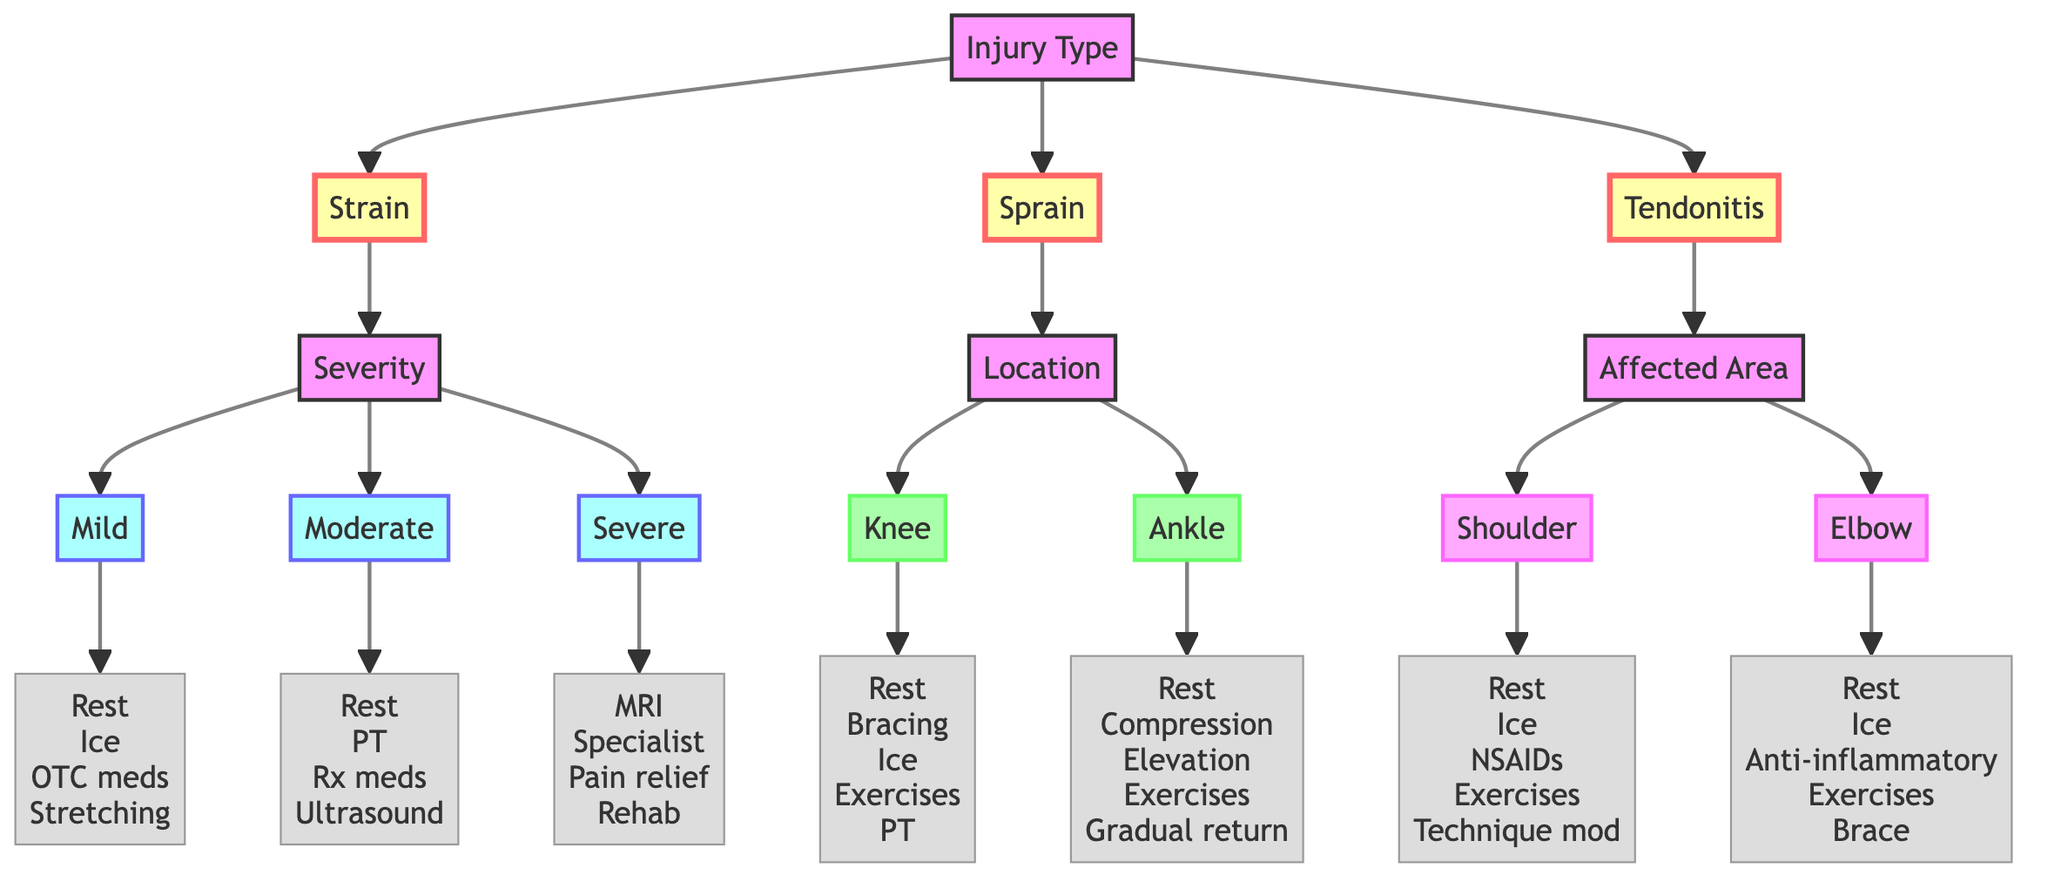What are the three injury types listed in this diagram? The diagram displays three injury types: Strain, Sprain, and Tendonitis which are the main branches stemming from the root node "Injury Type."
Answer: Strain, Sprain, Tendonitis What treatments are recommended for a severe strain? For a severe strain, the recommended treatments include MRI for detailed imaging, consultation with an orthopedic specialist, prescription pain relief, and a rehabilitation program, as indicated in the flowchart.
Answer: MRI, specialist, pain relief, rehab How many options are there under the "Sprain" injury type? The "Sprain" injury type has two options listed under it: Knee and Ankle, indicating the locations where the sprains can occur. Thus, there are two options.
Answer: 2 What is the node following the "Tendonitis" branch? The node following the "Tendonitis" branch is "Affected Area," which provides further classification of the injury by specifying the area that is affected, leading to subsequent specific areas.
Answer: Affected Area What is the treatment for "Elbow" tendonitis? The treatment options for "Elbow" tendonitis include rest, ice application, anti-inflammatory medication, forearm and grip strengthening exercises, and brace or support, as stated in the diagram.
Answer: Rest, Ice, Anti-inflammatory, Exercises, Brace If someone has a knee sprain, what is the first treatment they should consider? For a knee sprain, the first treatment recommended is rest. This comes from the flowchart, where "Rest" is listed as the first option under the knee location treatments.
Answer: Rest What is the common cause of shoulder tendonitis as noted in the diagram? The common cause of shoulder tendonitis is identified in the description as overhead movements and bench press, which are typical activities that can lead to this injury among powerlifters.
Answer: Overhead movements, bench press What are the mild strain treatments listed? The treatments for a mild strain include rest, ice application, over-the-counter anti-inflammatory medication, and light stretching, which are organized sequentially in the diagram under the mild strain category.
Answer: Rest, Ice, OTC meds, Stretching 